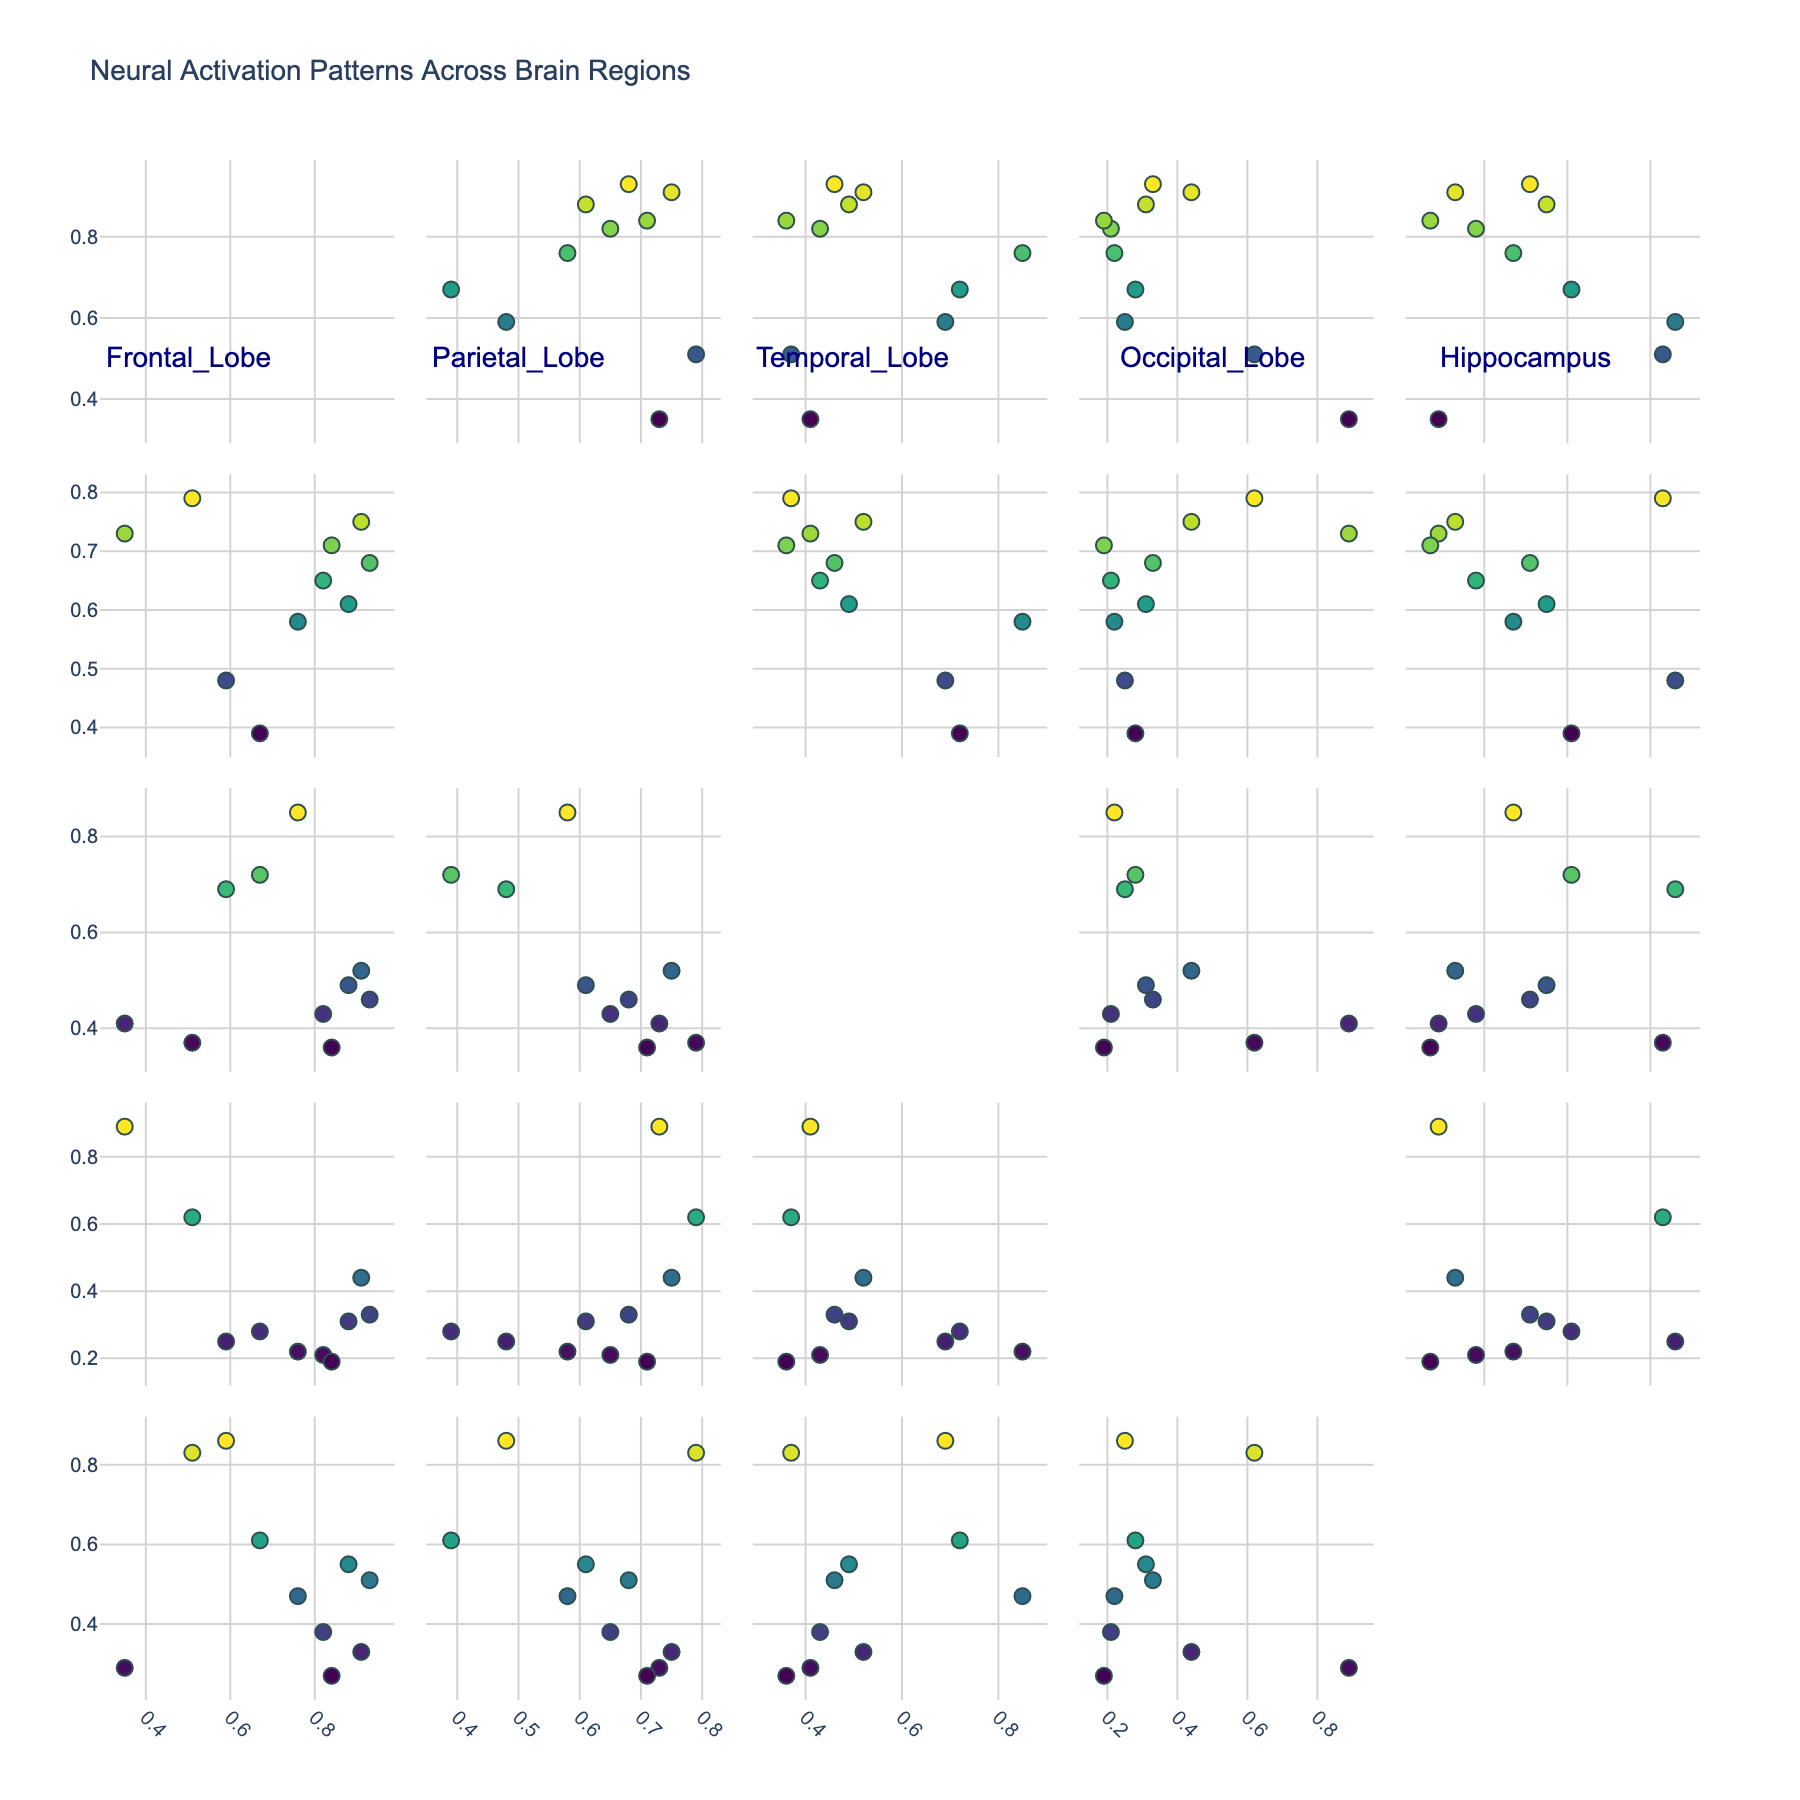What is the title of the figure? The title is usually displayed prominently at the top of the figure, summarizing what the plot is about. In this case, it is related to neural activation patterns across brain regions.
Answer: Neural Activation Patterns Across Brain Regions How many brain regions are analyzed in this scatterplot matrix? The number of brain regions corresponds to the number of unique variables plotted on both x and y axes. By counting these unique labels, we can determine the number of brain regions.
Answer: 5 Which brain region shows the highest activation level during the "Attention" task? Identify the row labeled "Attention" from the original dataset, then choose the region with the highest value in that row.
Answer: Frontal Lobe Is there a brain region that doesn't significantly activate during any task? By examining the scatterplot matrix, we can scan for regions (i.e., axes) that consistently show low values across all tasks.
Answer: No, all regions have significant activations in at least one task Which pair of brain regions seems to have the most positive correlation? Look for the scatterplots where the data points appear to form a line with a positive slope. The regions corresponding to these axes are likely the most positively correlated.
Answer: Frontal Lobe and Parietal Lobe During the "Problem_Solving" task, how does the activation level in the Hippocampus compare to the Frontal Lobe? Locate the "Problem_Solving" task data points for both the Hippocampus and the Frontal Lobe, then compare their values.
Answer: Hippocampus is lower Which cognitive task shows the highest activation in the Occipital_Lobe? Find the scatterplots involving the Occipital_Lobe and identify which data point along these axes goes the highest. Then, see which task it corresponds to.
Answer: Visual_Processing Is there a task where the Frontal_Lobe activation is consistently higher compared to the Parietal_Lobe? Compare the activation values of each task between the Frontal_Lobe and the Parietal_Lobe across multiple scatterplots and identify any consistent patterns.
Answer: No, not consistently Which task involves the highest activation level in the Hippocampus? Identify the scatterplot that includes the Hippocampus as one of the variables and find the task corresponding to the highest data point in that plot.
Answer: Memory_Retrieval Is there any task for which the activation levels of the Temporal_Lobe and Occipital_Lobe are approximately equal? For scatterplots involving both Temporal_Lobe and Occipital_Lobe, look for data points that are close to forming a diagonal line (y = x line). Identify the respective task.
Answer: No 